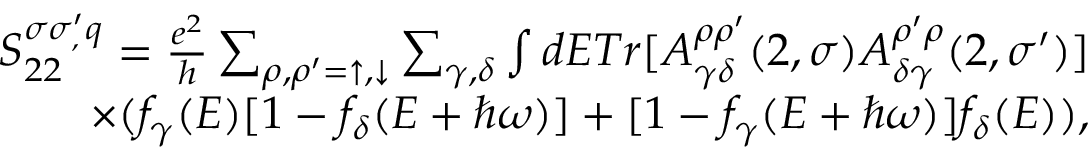Convert formula to latex. <formula><loc_0><loc_0><loc_500><loc_500>\begin{array} { r } { S _ { 2 2 } ^ { \sigma \sigma _ { , } ^ { \prime } q } = \frac { e ^ { 2 } } { h } \sum _ { \rho , \rho ^ { \prime } = \uparrow , \downarrow } \sum _ { \gamma , \delta } \int d E T r [ A _ { \gamma \delta } ^ { \rho \rho ^ { \prime } } ( 2 , \sigma ) A _ { \delta \gamma } ^ { \rho ^ { \prime } \rho } ( 2 , \sigma ^ { \prime } ) ] } \\ { \times ( f _ { \gamma } ( E ) [ 1 - f _ { \delta } ( E + \hbar { \omega } ) ] + [ 1 - f _ { \gamma } ( E + \hbar { \omega } ) ] f _ { \delta } ( E ) ) , } \end{array}</formula> 